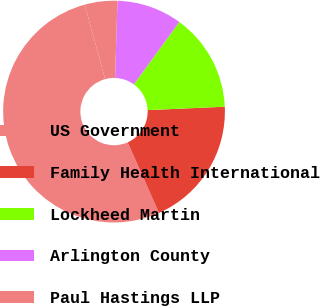<chart> <loc_0><loc_0><loc_500><loc_500><pie_chart><fcel>US Government<fcel>Family Health International<fcel>Lockheed Martin<fcel>Arlington County<fcel>Paul Hastings LLP<nl><fcel>52.39%<fcel>19.05%<fcel>14.28%<fcel>9.52%<fcel>4.76%<nl></chart> 